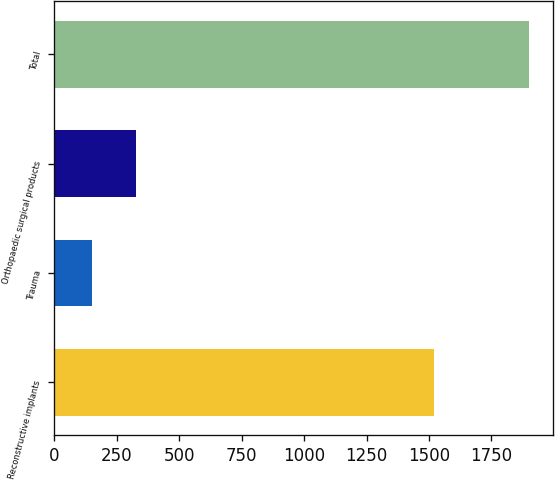Convert chart. <chart><loc_0><loc_0><loc_500><loc_500><bar_chart><fcel>Reconstructive implants<fcel>Trauma<fcel>Orthopaedic surgical products<fcel>Total<nl><fcel>1521<fcel>151.6<fcel>326.54<fcel>1901<nl></chart> 